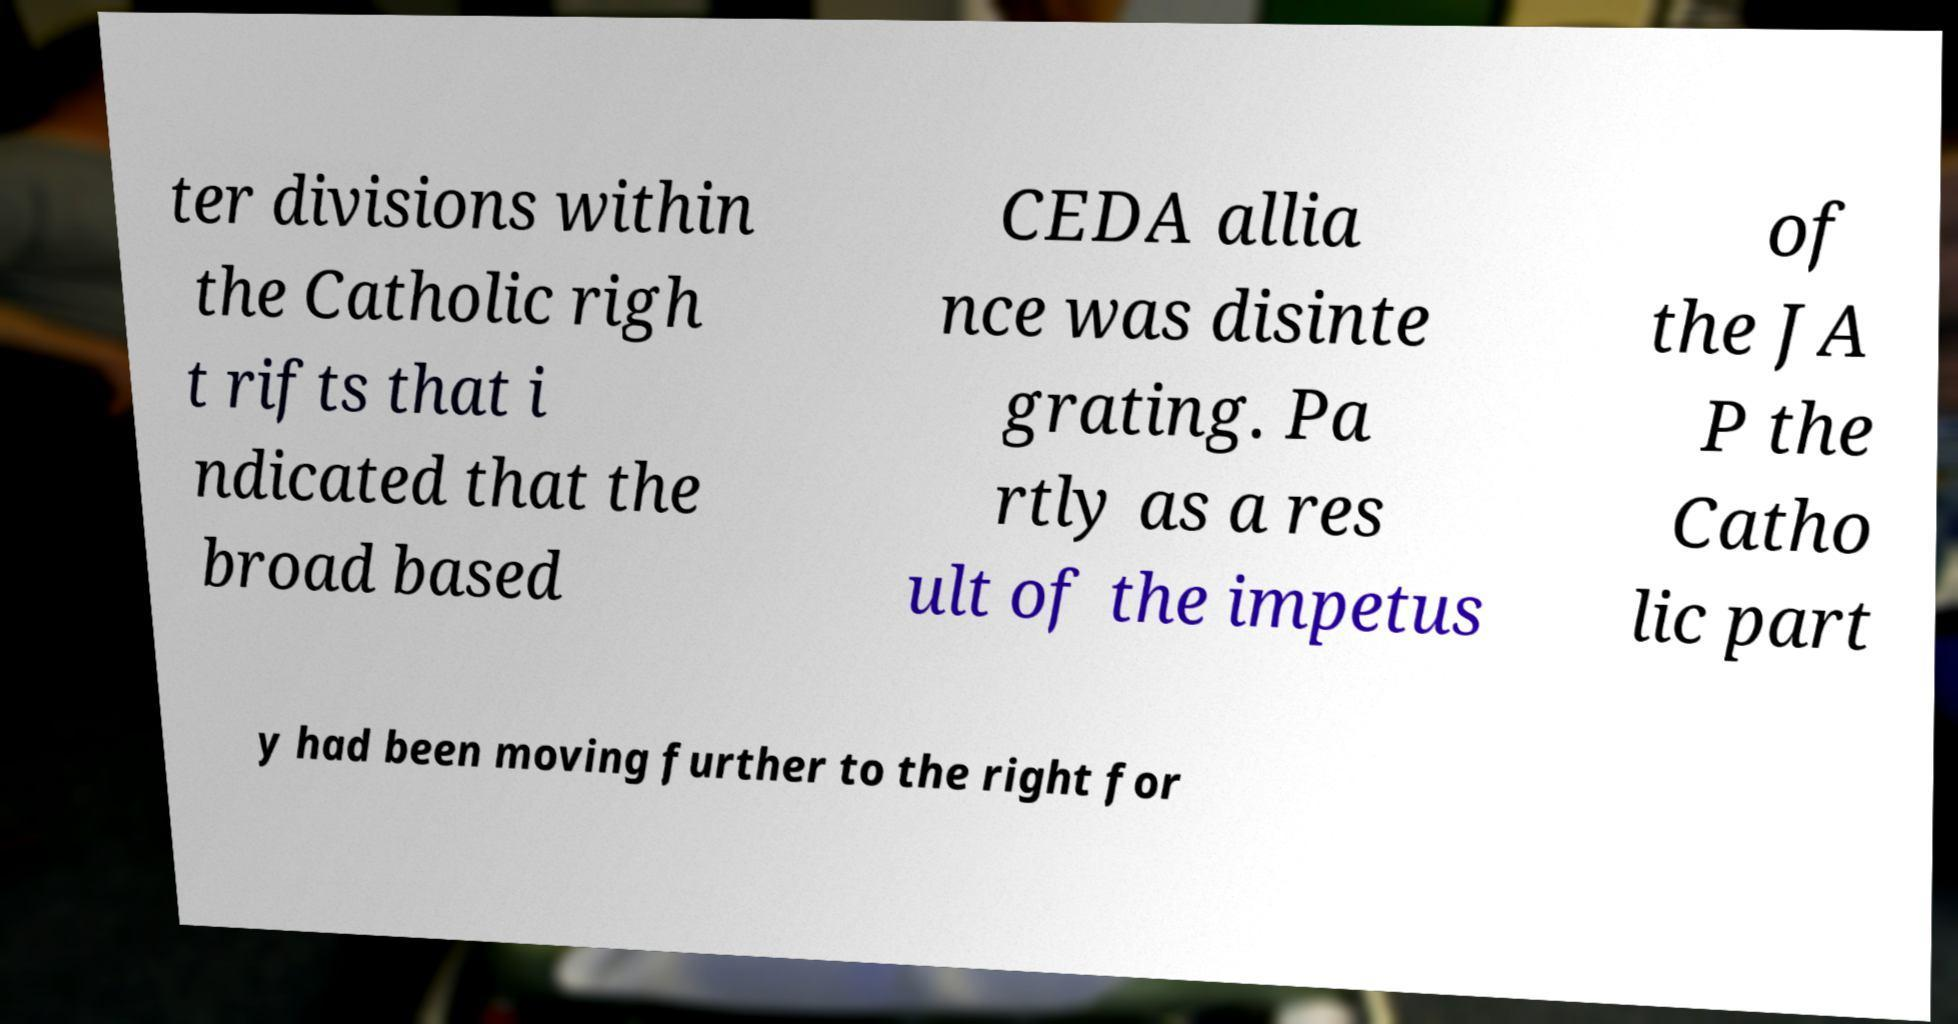Please read and relay the text visible in this image. What does it say? ter divisions within the Catholic righ t rifts that i ndicated that the broad based CEDA allia nce was disinte grating. Pa rtly as a res ult of the impetus of the JA P the Catho lic part y had been moving further to the right for 